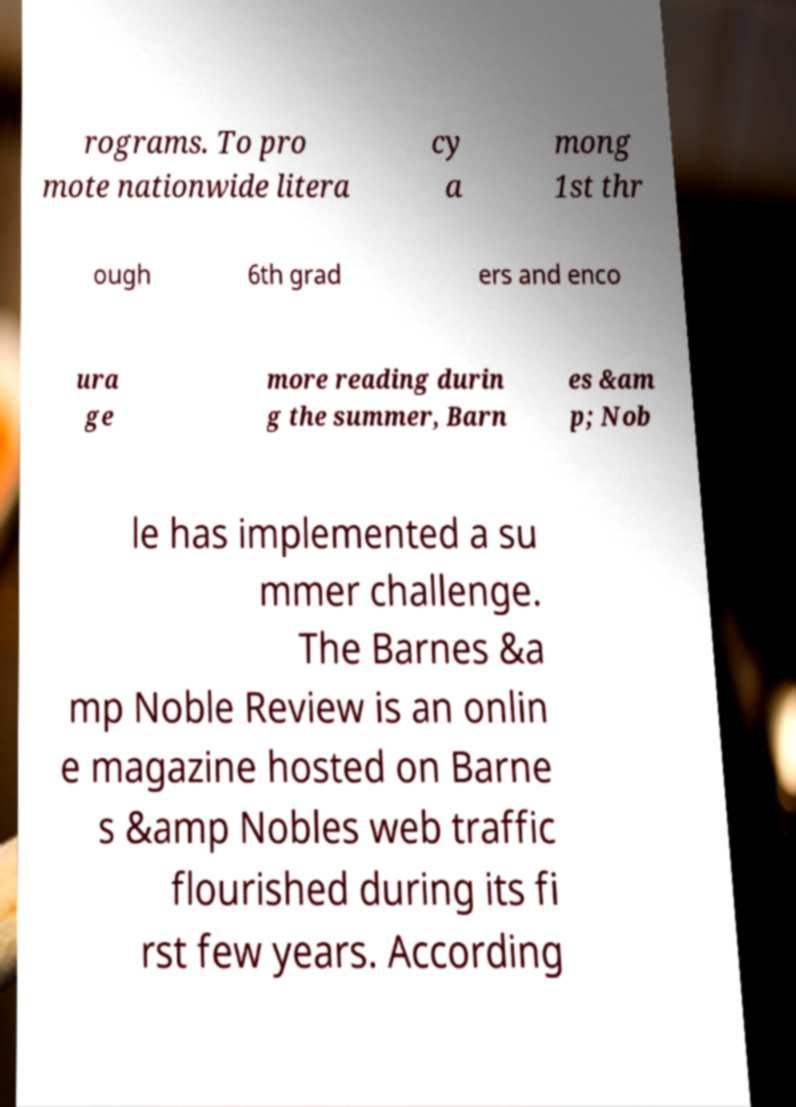Can you read and provide the text displayed in the image?This photo seems to have some interesting text. Can you extract and type it out for me? rograms. To pro mote nationwide litera cy a mong 1st thr ough 6th grad ers and enco ura ge more reading durin g the summer, Barn es &am p; Nob le has implemented a su mmer challenge. The Barnes &a mp Noble Review is an onlin e magazine hosted on Barne s &amp Nobles web traffic flourished during its fi rst few years. According 